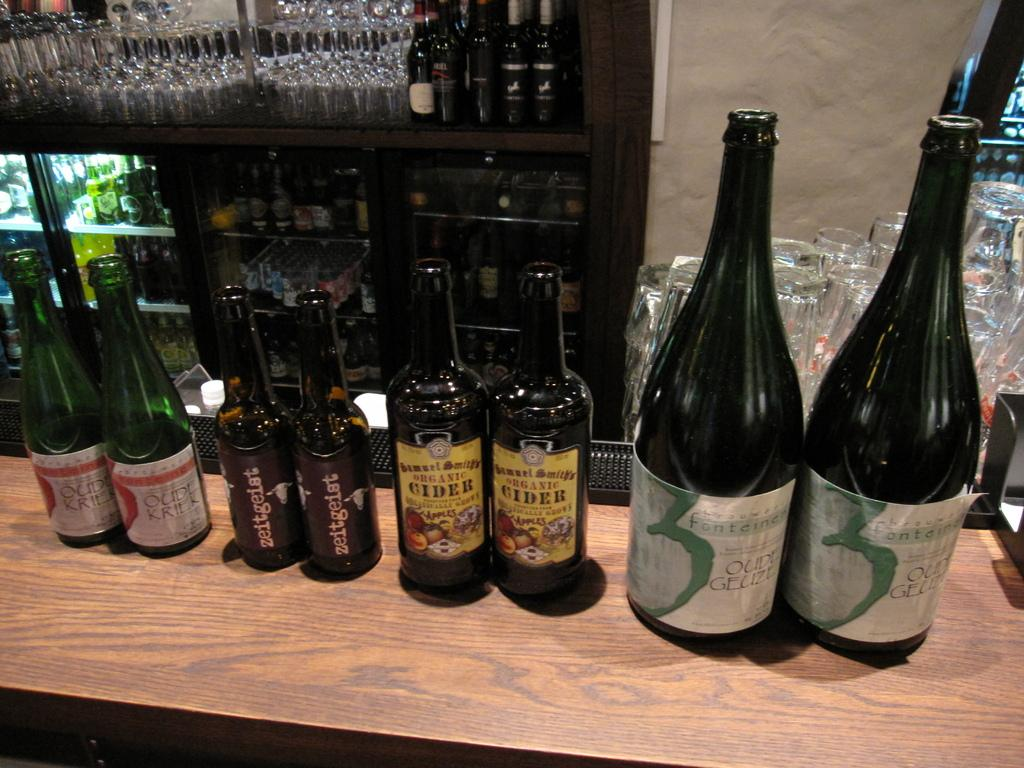<image>
Create a compact narrative representing the image presented. A couple of bottles of organic cider are surrounded by other bottles. 